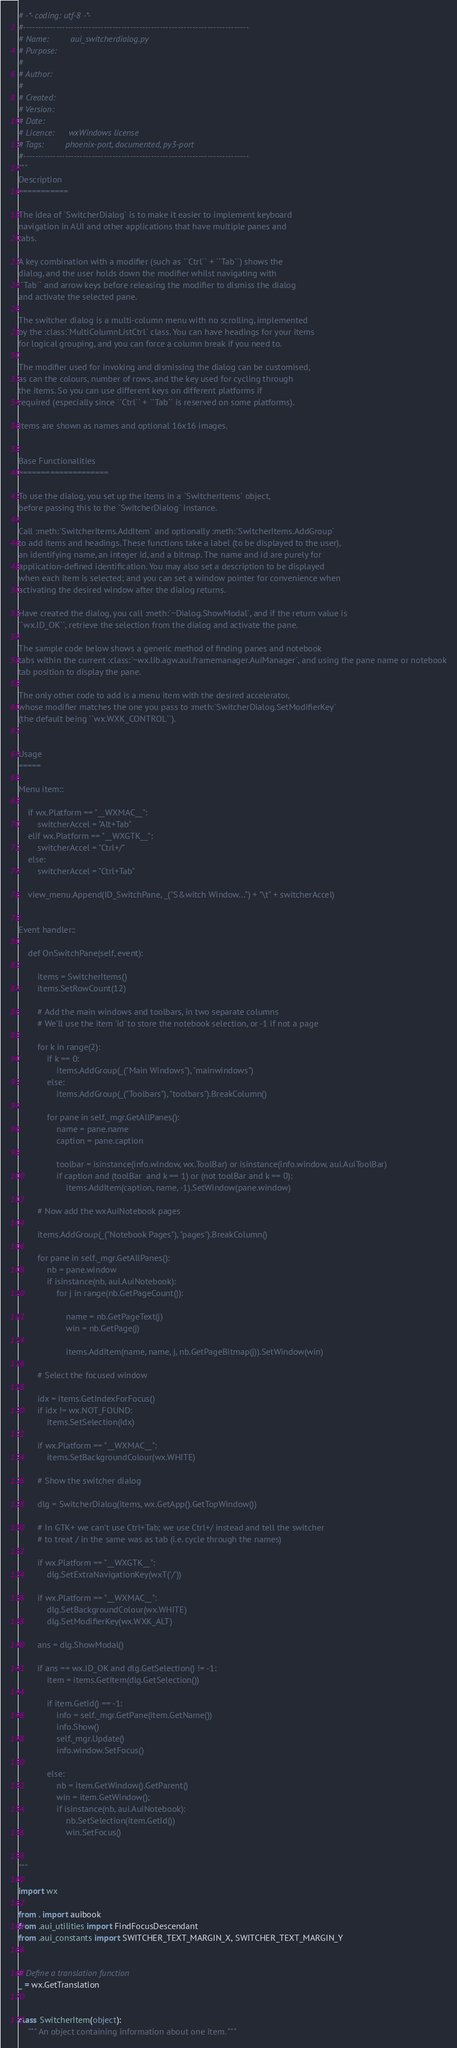<code> <loc_0><loc_0><loc_500><loc_500><_Python_># -*- coding: utf-8 -*-
#----------------------------------------------------------------------------
# Name:         aui_switcherdialog.py
# Purpose:
#
# Author:
#
# Created:
# Version:
# Date:
# Licence:      wxWindows license
# Tags:         phoenix-port, documented, py3-port
#----------------------------------------------------------------------------
"""
Description
===========

The idea of `SwitcherDialog` is to make it easier to implement keyboard
navigation in AUI and other applications that have multiple panes and
tabs.

A key combination with a modifier (such as ``Ctrl`` + ``Tab``) shows the
dialog, and the user holds down the modifier whilst navigating with
``Tab`` and arrow keys before releasing the modifier to dismiss the dialog
and activate the selected pane.

The switcher dialog is a multi-column menu with no scrolling, implemented
by the :class:`MultiColumnListCtrl` class. You can have headings for your items
for logical grouping, and you can force a column break if you need to.

The modifier used for invoking and dismissing the dialog can be customised,
as can the colours, number of rows, and the key used for cycling through
the items. So you can use different keys on different platforms if
required (especially since ``Ctrl`` + ``Tab`` is reserved on some platforms).

Items are shown as names and optional 16x16 images.


Base Functionalities
====================

To use the dialog, you set up the items in a `SwitcherItems` object,
before passing this to the `SwitcherDialog` instance.

Call :meth:`SwitcherItems.AddItem` and optionally :meth:`SwitcherItems.AddGroup`
to add items and headings. These functions take a label (to be displayed to the user),
an identifying name, an integer id, and a bitmap. The name and id are purely for
application-defined identification. You may also set a description to be displayed
when each item is selected; and you can set a window pointer for convenience when
activating the desired window after the dialog returns.

Have created the dialog, you call :meth:`~Dialog.ShowModal`, and if the return value is
``wx.ID_OK``, retrieve the selection from the dialog and activate the pane.

The sample code below shows a generic method of finding panes and notebook
tabs within the current :class:`~wx.lib.agw.aui.framemanager.AuiManager`, and using the pane name or notebook
tab position to display the pane.

The only other code to add is a menu item with the desired accelerator,
whose modifier matches the one you pass to :meth:`SwitcherDialog.SetModifierKey`
(the default being ``wx.WXK_CONTROL``).


Usage
=====

Menu item::

    if wx.Platform == "__WXMAC__":
        switcherAccel = "Alt+Tab"
    elif wx.Platform == "__WXGTK__":
        switcherAccel = "Ctrl+/"
    else:
        switcherAccel = "Ctrl+Tab"

    view_menu.Append(ID_SwitchPane, _("S&witch Window...") + "\t" + switcherAccel)


Event handler::

    def OnSwitchPane(self, event):

        items = SwitcherItems()
        items.SetRowCount(12)

        # Add the main windows and toolbars, in two separate columns
        # We'll use the item 'id' to store the notebook selection, or -1 if not a page

        for k in range(2):
            if k == 0:
                items.AddGroup(_("Main Windows"), "mainwindows")
            else:
                items.AddGroup(_("Toolbars"), "toolbars").BreakColumn()

            for pane in self._mgr.GetAllPanes():
                name = pane.name
                caption = pane.caption

                toolbar = isinstance(info.window, wx.ToolBar) or isinstance(info.window, aui.AuiToolBar)
                if caption and (toolBar  and k == 1) or (not toolBar and k == 0):
                    items.AddItem(caption, name, -1).SetWindow(pane.window)

        # Now add the wxAuiNotebook pages

        items.AddGroup(_("Notebook Pages"), "pages").BreakColumn()

        for pane in self._mgr.GetAllPanes():
            nb = pane.window
            if isinstance(nb, aui.AuiNotebook):
                for j in range(nb.GetPageCount()):

                    name = nb.GetPageText(j)
                    win = nb.GetPage(j)

                    items.AddItem(name, name, j, nb.GetPageBitmap(j)).SetWindow(win)

        # Select the focused window

        idx = items.GetIndexForFocus()
        if idx != wx.NOT_FOUND:
            items.SetSelection(idx)

        if wx.Platform == "__WXMAC__":
            items.SetBackgroundColour(wx.WHITE)

        # Show the switcher dialog

        dlg = SwitcherDialog(items, wx.GetApp().GetTopWindow())

        # In GTK+ we can't use Ctrl+Tab; we use Ctrl+/ instead and tell the switcher
        # to treat / in the same was as tab (i.e. cycle through the names)

        if wx.Platform == "__WXGTK__":
            dlg.SetExtraNavigationKey(wxT('/'))

        if wx.Platform == "__WXMAC__":
            dlg.SetBackgroundColour(wx.WHITE)
            dlg.SetModifierKey(wx.WXK_ALT)

        ans = dlg.ShowModal()

        if ans == wx.ID_OK and dlg.GetSelection() != -1:
            item = items.GetItem(dlg.GetSelection())

            if item.GetId() == -1:
                info = self._mgr.GetPane(item.GetName())
                info.Show()
                self._mgr.Update()
                info.window.SetFocus()

            else:
                nb = item.GetWindow().GetParent()
                win = item.GetWindow();
                if isinstance(nb, aui.AuiNotebook):
                    nb.SetSelection(item.GetId())
                    win.SetFocus()


"""

import wx

from . import auibook
from .aui_utilities import FindFocusDescendant
from .aui_constants import SWITCHER_TEXT_MARGIN_X, SWITCHER_TEXT_MARGIN_Y


# Define a translation function
_ = wx.GetTranslation


class SwitcherItem(object):
    """ An object containing information about one item. """
</code> 